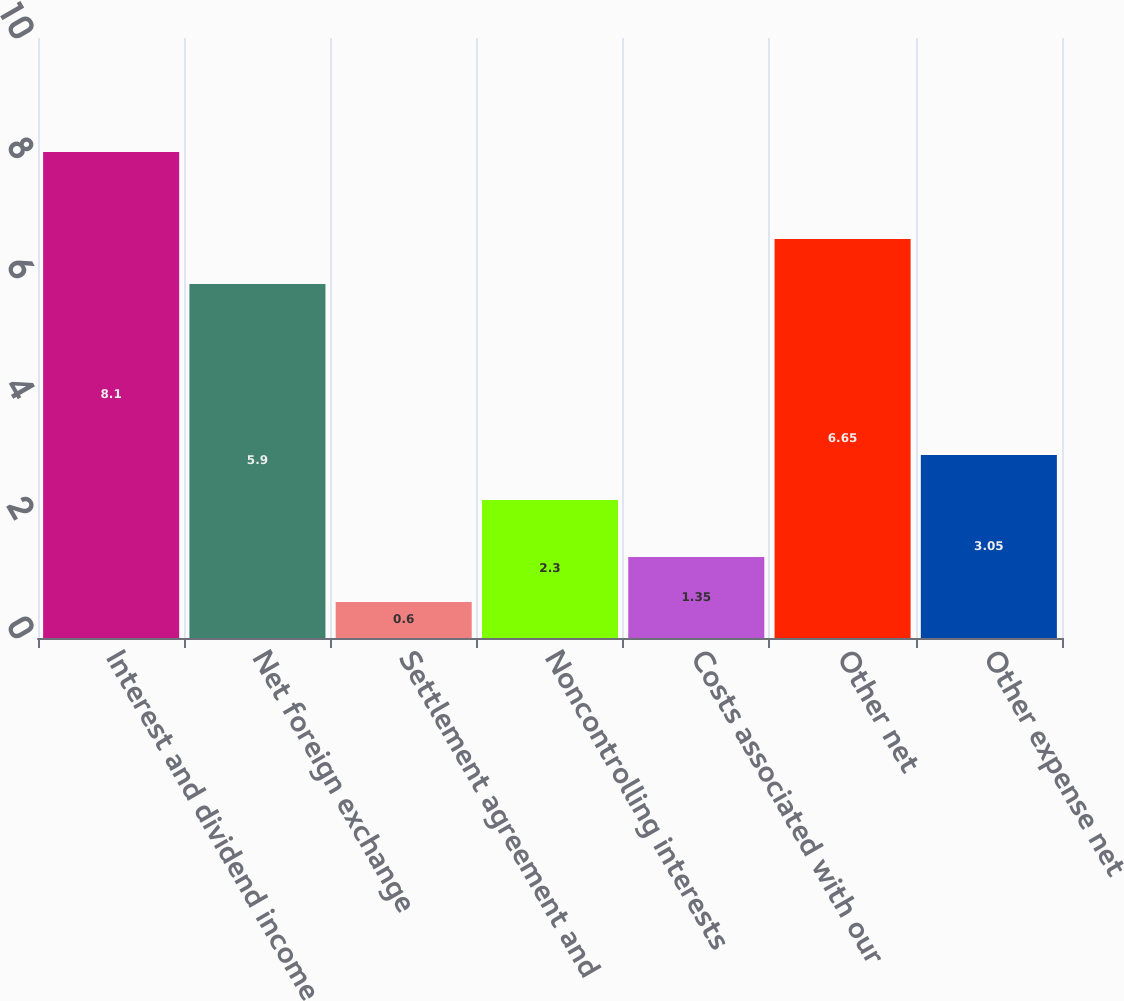Convert chart to OTSL. <chart><loc_0><loc_0><loc_500><loc_500><bar_chart><fcel>Interest and dividend income<fcel>Net foreign exchange<fcel>Settlement agreement and<fcel>Noncontrolling interests<fcel>Costs associated with our<fcel>Other net<fcel>Other expense net<nl><fcel>8.1<fcel>5.9<fcel>0.6<fcel>2.3<fcel>1.35<fcel>6.65<fcel>3.05<nl></chart> 